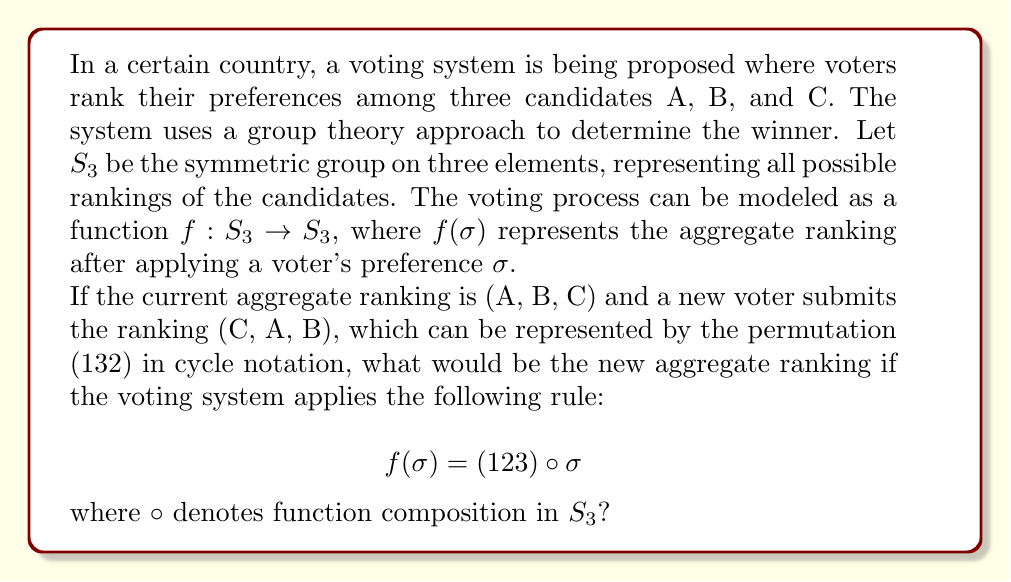Solve this math problem. To solve this problem, we need to follow these steps:

1) First, let's recall that in $S_3$, we read permutations from right to left when composing them.

2) The current aggregate ranking (A, B, C) is represented by the identity permutation $(1)$ or simply $e$ in $S_3$.

3) The new voter's ranking (C, A, B) is represented by the permutation $(1 3 2)$ in cycle notation.

4) The voting system applies the rule $f(\sigma) = (1 2 3) \circ \sigma$ to each new vote.

5) So, we need to compute $(1 2 3) \circ (1 3 2)$:

   Let's apply these permutations to each element:
   1 → 3 → 2
   2 → 1 → 3
   3 → 2 → 1

6) This results in the permutation $(1 2 3)$.

7) Now, we need to interpret this permutation in terms of the candidates:
   (1 2 3) means:
   1 (A) moves to position 2
   2 (B) moves to position 3
   3 (C) moves to position 1

8) Therefore, the new aggregate ranking is (C, A, B).

This group theory approach allows us to model and analyze voting systems mathematically, providing insights into their properties and behavior.
Answer: The new aggregate ranking after applying the voting rule is (C, A, B). 